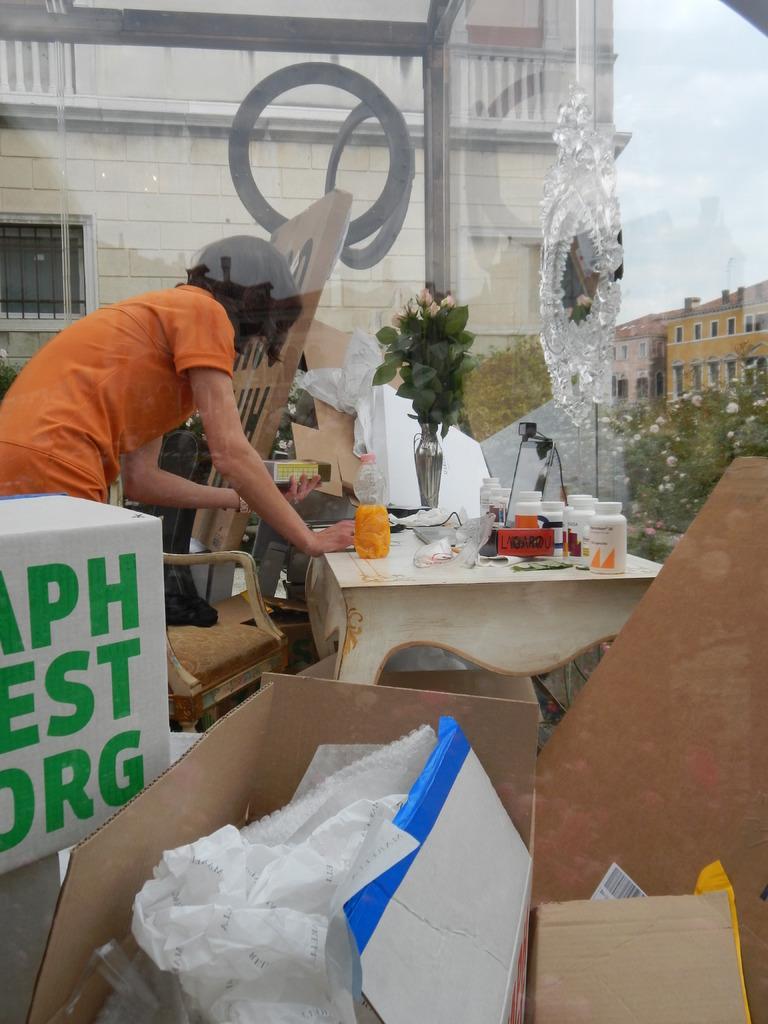In one or two sentences, can you explain what this image depicts? In this image I can see few cardboard boxes which are brown in color and in the boxes I can see few white colored objects. I can see a person wearing orange colored dress is standing, a chair, a table and on the table I can see few bottles, a flower vase and few other objects. In the background I can see few buildings, few trees and the sky. 